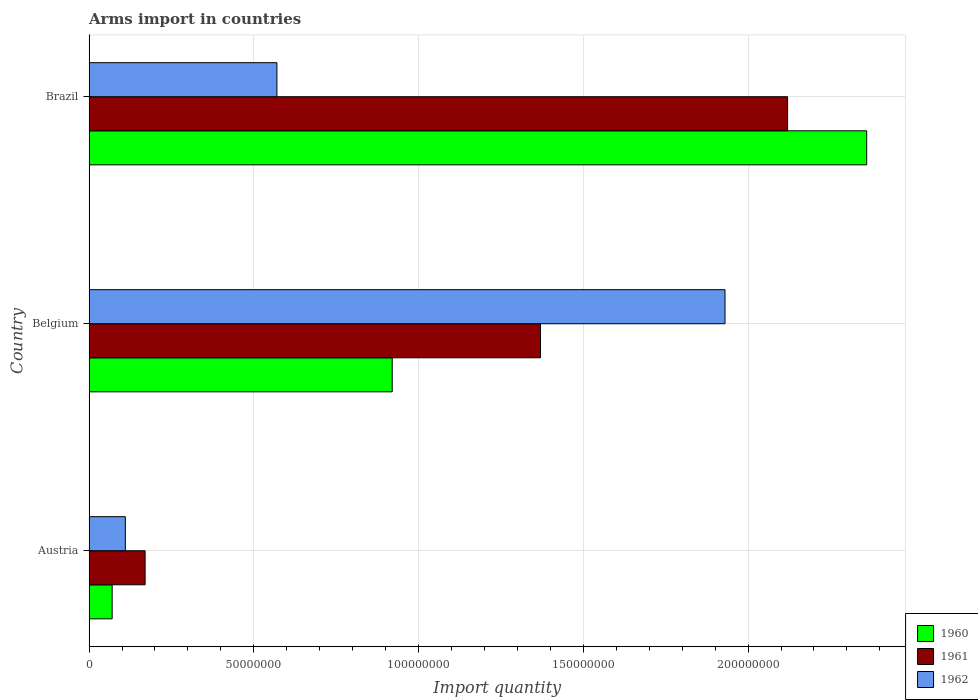How many different coloured bars are there?
Provide a short and direct response. 3. Are the number of bars per tick equal to the number of legend labels?
Offer a very short reply. Yes. Are the number of bars on each tick of the Y-axis equal?
Provide a succinct answer. Yes. How many bars are there on the 3rd tick from the top?
Your response must be concise. 3. What is the label of the 1st group of bars from the top?
Your response must be concise. Brazil. In how many cases, is the number of bars for a given country not equal to the number of legend labels?
Make the answer very short. 0. What is the total arms import in 1960 in Brazil?
Ensure brevity in your answer.  2.36e+08. Across all countries, what is the maximum total arms import in 1961?
Provide a short and direct response. 2.12e+08. Across all countries, what is the minimum total arms import in 1961?
Ensure brevity in your answer.  1.70e+07. What is the total total arms import in 1961 in the graph?
Make the answer very short. 3.66e+08. What is the difference between the total arms import in 1960 in Austria and that in Belgium?
Make the answer very short. -8.50e+07. What is the difference between the total arms import in 1962 in Austria and the total arms import in 1960 in Belgium?
Ensure brevity in your answer.  -8.10e+07. What is the average total arms import in 1962 per country?
Ensure brevity in your answer.  8.70e+07. What is the difference between the total arms import in 1960 and total arms import in 1961 in Belgium?
Keep it short and to the point. -4.50e+07. In how many countries, is the total arms import in 1961 greater than 130000000 ?
Offer a terse response. 2. What is the ratio of the total arms import in 1960 in Austria to that in Brazil?
Offer a very short reply. 0.03. Is the total arms import in 1960 in Austria less than that in Brazil?
Provide a short and direct response. Yes. Is the difference between the total arms import in 1960 in Belgium and Brazil greater than the difference between the total arms import in 1961 in Belgium and Brazil?
Ensure brevity in your answer.  No. What is the difference between the highest and the second highest total arms import in 1960?
Your answer should be very brief. 1.44e+08. What is the difference between the highest and the lowest total arms import in 1962?
Your answer should be very brief. 1.82e+08. In how many countries, is the total arms import in 1961 greater than the average total arms import in 1961 taken over all countries?
Make the answer very short. 2. Is the sum of the total arms import in 1962 in Austria and Belgium greater than the maximum total arms import in 1961 across all countries?
Offer a very short reply. No. What does the 3rd bar from the top in Brazil represents?
Make the answer very short. 1960. What does the 3rd bar from the bottom in Brazil represents?
Your response must be concise. 1962. Is it the case that in every country, the sum of the total arms import in 1962 and total arms import in 1960 is greater than the total arms import in 1961?
Ensure brevity in your answer.  Yes. How many bars are there?
Make the answer very short. 9. How many countries are there in the graph?
Provide a succinct answer. 3. What is the difference between two consecutive major ticks on the X-axis?
Offer a terse response. 5.00e+07. Does the graph contain any zero values?
Ensure brevity in your answer.  No. How many legend labels are there?
Make the answer very short. 3. What is the title of the graph?
Make the answer very short. Arms import in countries. Does "1973" appear as one of the legend labels in the graph?
Provide a short and direct response. No. What is the label or title of the X-axis?
Give a very brief answer. Import quantity. What is the Import quantity of 1961 in Austria?
Ensure brevity in your answer.  1.70e+07. What is the Import quantity of 1962 in Austria?
Your answer should be very brief. 1.10e+07. What is the Import quantity of 1960 in Belgium?
Provide a short and direct response. 9.20e+07. What is the Import quantity of 1961 in Belgium?
Offer a very short reply. 1.37e+08. What is the Import quantity of 1962 in Belgium?
Your answer should be very brief. 1.93e+08. What is the Import quantity of 1960 in Brazil?
Offer a terse response. 2.36e+08. What is the Import quantity in 1961 in Brazil?
Your response must be concise. 2.12e+08. What is the Import quantity of 1962 in Brazil?
Provide a succinct answer. 5.70e+07. Across all countries, what is the maximum Import quantity of 1960?
Make the answer very short. 2.36e+08. Across all countries, what is the maximum Import quantity in 1961?
Make the answer very short. 2.12e+08. Across all countries, what is the maximum Import quantity of 1962?
Give a very brief answer. 1.93e+08. Across all countries, what is the minimum Import quantity of 1960?
Offer a terse response. 7.00e+06. Across all countries, what is the minimum Import quantity of 1961?
Provide a succinct answer. 1.70e+07. Across all countries, what is the minimum Import quantity in 1962?
Your answer should be compact. 1.10e+07. What is the total Import quantity of 1960 in the graph?
Keep it short and to the point. 3.35e+08. What is the total Import quantity in 1961 in the graph?
Keep it short and to the point. 3.66e+08. What is the total Import quantity in 1962 in the graph?
Offer a terse response. 2.61e+08. What is the difference between the Import quantity in 1960 in Austria and that in Belgium?
Your answer should be compact. -8.50e+07. What is the difference between the Import quantity of 1961 in Austria and that in Belgium?
Your answer should be very brief. -1.20e+08. What is the difference between the Import quantity in 1962 in Austria and that in Belgium?
Provide a succinct answer. -1.82e+08. What is the difference between the Import quantity of 1960 in Austria and that in Brazil?
Ensure brevity in your answer.  -2.29e+08. What is the difference between the Import quantity of 1961 in Austria and that in Brazil?
Provide a succinct answer. -1.95e+08. What is the difference between the Import quantity in 1962 in Austria and that in Brazil?
Offer a very short reply. -4.60e+07. What is the difference between the Import quantity in 1960 in Belgium and that in Brazil?
Offer a terse response. -1.44e+08. What is the difference between the Import quantity of 1961 in Belgium and that in Brazil?
Offer a terse response. -7.50e+07. What is the difference between the Import quantity of 1962 in Belgium and that in Brazil?
Make the answer very short. 1.36e+08. What is the difference between the Import quantity of 1960 in Austria and the Import quantity of 1961 in Belgium?
Your answer should be very brief. -1.30e+08. What is the difference between the Import quantity of 1960 in Austria and the Import quantity of 1962 in Belgium?
Make the answer very short. -1.86e+08. What is the difference between the Import quantity in 1961 in Austria and the Import quantity in 1962 in Belgium?
Your answer should be very brief. -1.76e+08. What is the difference between the Import quantity in 1960 in Austria and the Import quantity in 1961 in Brazil?
Your answer should be very brief. -2.05e+08. What is the difference between the Import quantity of 1960 in Austria and the Import quantity of 1962 in Brazil?
Your response must be concise. -5.00e+07. What is the difference between the Import quantity in 1961 in Austria and the Import quantity in 1962 in Brazil?
Ensure brevity in your answer.  -4.00e+07. What is the difference between the Import quantity of 1960 in Belgium and the Import quantity of 1961 in Brazil?
Your answer should be very brief. -1.20e+08. What is the difference between the Import quantity of 1960 in Belgium and the Import quantity of 1962 in Brazil?
Ensure brevity in your answer.  3.50e+07. What is the difference between the Import quantity in 1961 in Belgium and the Import quantity in 1962 in Brazil?
Make the answer very short. 8.00e+07. What is the average Import quantity of 1960 per country?
Provide a succinct answer. 1.12e+08. What is the average Import quantity of 1961 per country?
Provide a succinct answer. 1.22e+08. What is the average Import quantity in 1962 per country?
Provide a short and direct response. 8.70e+07. What is the difference between the Import quantity in 1960 and Import quantity in 1961 in Austria?
Keep it short and to the point. -1.00e+07. What is the difference between the Import quantity of 1960 and Import quantity of 1962 in Austria?
Give a very brief answer. -4.00e+06. What is the difference between the Import quantity of 1961 and Import quantity of 1962 in Austria?
Offer a terse response. 6.00e+06. What is the difference between the Import quantity of 1960 and Import quantity of 1961 in Belgium?
Give a very brief answer. -4.50e+07. What is the difference between the Import quantity of 1960 and Import quantity of 1962 in Belgium?
Offer a very short reply. -1.01e+08. What is the difference between the Import quantity in 1961 and Import quantity in 1962 in Belgium?
Provide a succinct answer. -5.60e+07. What is the difference between the Import quantity of 1960 and Import quantity of 1961 in Brazil?
Your answer should be very brief. 2.40e+07. What is the difference between the Import quantity in 1960 and Import quantity in 1962 in Brazil?
Keep it short and to the point. 1.79e+08. What is the difference between the Import quantity of 1961 and Import quantity of 1962 in Brazil?
Provide a short and direct response. 1.55e+08. What is the ratio of the Import quantity of 1960 in Austria to that in Belgium?
Offer a very short reply. 0.08. What is the ratio of the Import quantity of 1961 in Austria to that in Belgium?
Provide a short and direct response. 0.12. What is the ratio of the Import quantity in 1962 in Austria to that in Belgium?
Keep it short and to the point. 0.06. What is the ratio of the Import quantity in 1960 in Austria to that in Brazil?
Keep it short and to the point. 0.03. What is the ratio of the Import quantity of 1961 in Austria to that in Brazil?
Your answer should be compact. 0.08. What is the ratio of the Import quantity in 1962 in Austria to that in Brazil?
Your answer should be very brief. 0.19. What is the ratio of the Import quantity of 1960 in Belgium to that in Brazil?
Provide a short and direct response. 0.39. What is the ratio of the Import quantity in 1961 in Belgium to that in Brazil?
Your answer should be very brief. 0.65. What is the ratio of the Import quantity of 1962 in Belgium to that in Brazil?
Offer a very short reply. 3.39. What is the difference between the highest and the second highest Import quantity of 1960?
Your response must be concise. 1.44e+08. What is the difference between the highest and the second highest Import quantity of 1961?
Your answer should be very brief. 7.50e+07. What is the difference between the highest and the second highest Import quantity of 1962?
Offer a terse response. 1.36e+08. What is the difference between the highest and the lowest Import quantity of 1960?
Your answer should be compact. 2.29e+08. What is the difference between the highest and the lowest Import quantity in 1961?
Give a very brief answer. 1.95e+08. What is the difference between the highest and the lowest Import quantity of 1962?
Offer a terse response. 1.82e+08. 